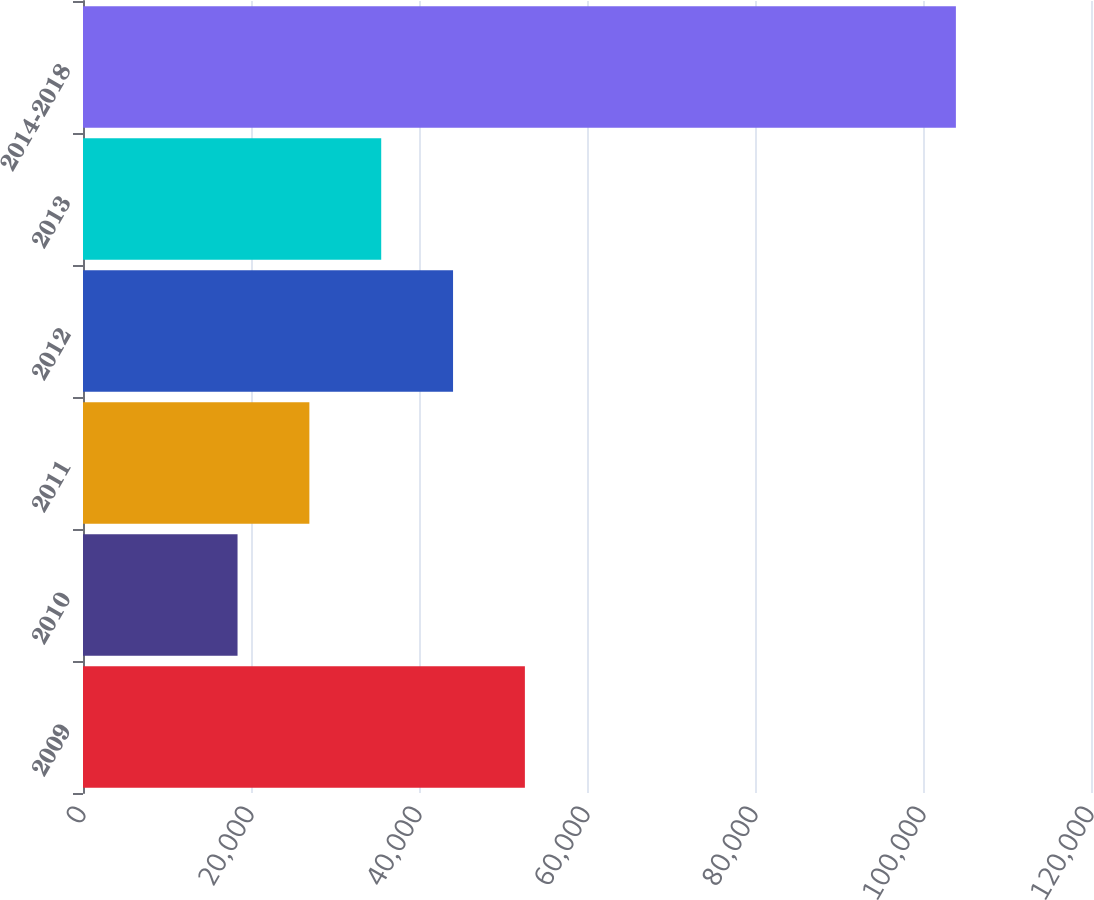Convert chart. <chart><loc_0><loc_0><loc_500><loc_500><bar_chart><fcel>2009<fcel>2010<fcel>2011<fcel>2012<fcel>2013<fcel>2014-2018<nl><fcel>52605.2<fcel>18398<fcel>26949.8<fcel>44053.4<fcel>35501.6<fcel>103916<nl></chart> 